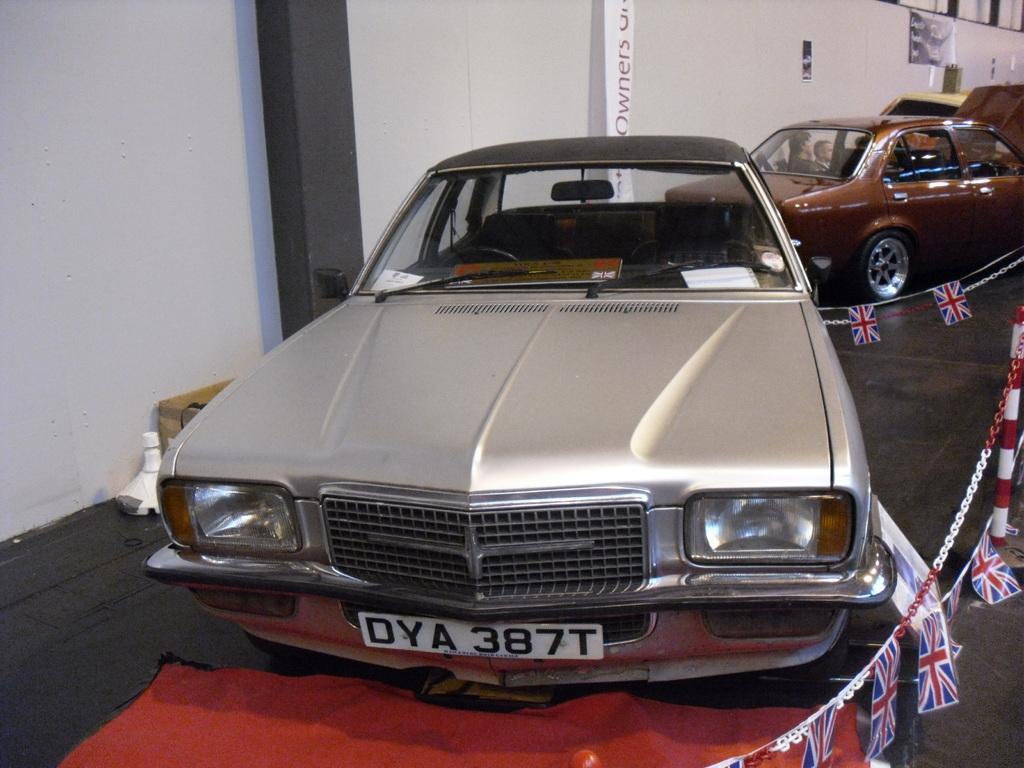How would you summarize this image in a sentence or two? In this image we can see some cars which are of different colors and same model and at the background of the image there are some persons sitting in the car, there is wall. 